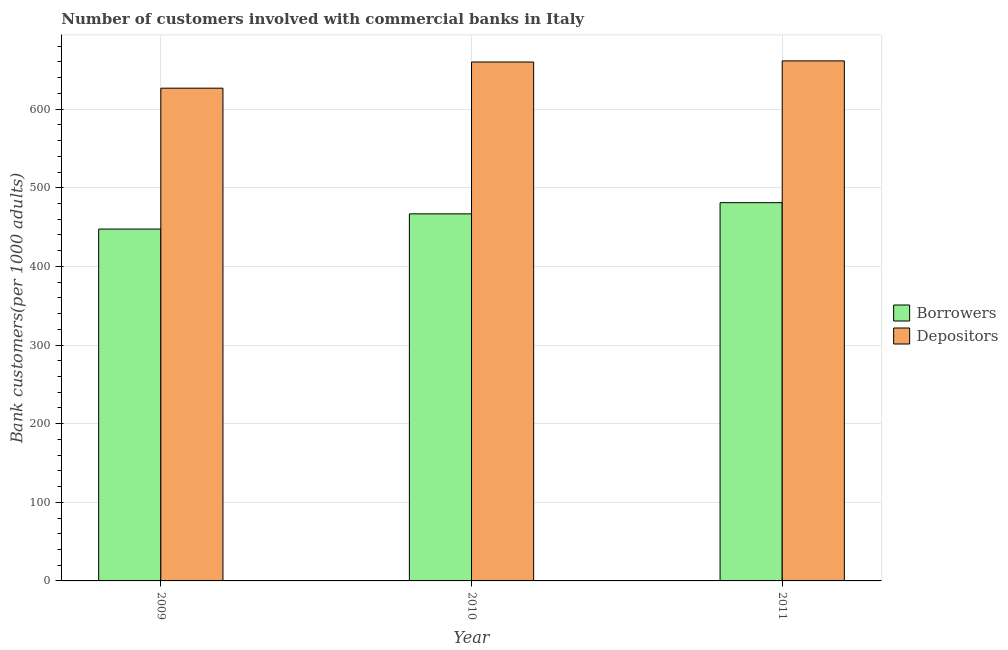How many different coloured bars are there?
Your answer should be very brief. 2. Are the number of bars per tick equal to the number of legend labels?
Keep it short and to the point. Yes. How many bars are there on the 2nd tick from the right?
Give a very brief answer. 2. What is the label of the 3rd group of bars from the left?
Ensure brevity in your answer.  2011. What is the number of borrowers in 2011?
Your answer should be compact. 481.07. Across all years, what is the maximum number of depositors?
Provide a succinct answer. 661.41. Across all years, what is the minimum number of borrowers?
Offer a very short reply. 447.49. In which year was the number of borrowers maximum?
Offer a terse response. 2011. In which year was the number of borrowers minimum?
Your answer should be compact. 2009. What is the total number of borrowers in the graph?
Your answer should be compact. 1395.41. What is the difference between the number of borrowers in 2009 and that in 2010?
Ensure brevity in your answer.  -19.36. What is the difference between the number of borrowers in 2009 and the number of depositors in 2010?
Offer a terse response. -19.36. What is the average number of depositors per year?
Ensure brevity in your answer.  649.36. In how many years, is the number of depositors greater than 180?
Keep it short and to the point. 3. What is the ratio of the number of depositors in 2009 to that in 2010?
Your answer should be compact. 0.95. Is the number of depositors in 2010 less than that in 2011?
Ensure brevity in your answer.  Yes. Is the difference between the number of depositors in 2009 and 2011 greater than the difference between the number of borrowers in 2009 and 2011?
Offer a terse response. No. What is the difference between the highest and the second highest number of depositors?
Your answer should be compact. 1.43. What is the difference between the highest and the lowest number of borrowers?
Provide a short and direct response. 33.58. In how many years, is the number of borrowers greater than the average number of borrowers taken over all years?
Offer a very short reply. 2. Is the sum of the number of borrowers in 2009 and 2011 greater than the maximum number of depositors across all years?
Provide a succinct answer. Yes. What does the 1st bar from the left in 2009 represents?
Provide a succinct answer. Borrowers. What does the 2nd bar from the right in 2010 represents?
Offer a terse response. Borrowers. How many bars are there?
Provide a succinct answer. 6. Are all the bars in the graph horizontal?
Ensure brevity in your answer.  No. What is the difference between two consecutive major ticks on the Y-axis?
Your response must be concise. 100. Does the graph contain grids?
Your answer should be very brief. Yes. How many legend labels are there?
Your answer should be compact. 2. How are the legend labels stacked?
Your answer should be compact. Vertical. What is the title of the graph?
Give a very brief answer. Number of customers involved with commercial banks in Italy. What is the label or title of the Y-axis?
Provide a succinct answer. Bank customers(per 1000 adults). What is the Bank customers(per 1000 adults) in Borrowers in 2009?
Ensure brevity in your answer.  447.49. What is the Bank customers(per 1000 adults) of Depositors in 2009?
Your answer should be very brief. 626.68. What is the Bank customers(per 1000 adults) of Borrowers in 2010?
Give a very brief answer. 466.85. What is the Bank customers(per 1000 adults) of Depositors in 2010?
Give a very brief answer. 659.98. What is the Bank customers(per 1000 adults) in Borrowers in 2011?
Ensure brevity in your answer.  481.07. What is the Bank customers(per 1000 adults) in Depositors in 2011?
Provide a succinct answer. 661.41. Across all years, what is the maximum Bank customers(per 1000 adults) in Borrowers?
Offer a very short reply. 481.07. Across all years, what is the maximum Bank customers(per 1000 adults) in Depositors?
Your answer should be compact. 661.41. Across all years, what is the minimum Bank customers(per 1000 adults) of Borrowers?
Provide a short and direct response. 447.49. Across all years, what is the minimum Bank customers(per 1000 adults) in Depositors?
Make the answer very short. 626.68. What is the total Bank customers(per 1000 adults) of Borrowers in the graph?
Provide a short and direct response. 1395.41. What is the total Bank customers(per 1000 adults) of Depositors in the graph?
Give a very brief answer. 1948.07. What is the difference between the Bank customers(per 1000 adults) in Borrowers in 2009 and that in 2010?
Keep it short and to the point. -19.36. What is the difference between the Bank customers(per 1000 adults) in Depositors in 2009 and that in 2010?
Offer a terse response. -33.3. What is the difference between the Bank customers(per 1000 adults) of Borrowers in 2009 and that in 2011?
Offer a very short reply. -33.58. What is the difference between the Bank customers(per 1000 adults) of Depositors in 2009 and that in 2011?
Ensure brevity in your answer.  -34.73. What is the difference between the Bank customers(per 1000 adults) of Borrowers in 2010 and that in 2011?
Provide a short and direct response. -14.22. What is the difference between the Bank customers(per 1000 adults) of Depositors in 2010 and that in 2011?
Provide a succinct answer. -1.43. What is the difference between the Bank customers(per 1000 adults) in Borrowers in 2009 and the Bank customers(per 1000 adults) in Depositors in 2010?
Your answer should be compact. -212.49. What is the difference between the Bank customers(per 1000 adults) in Borrowers in 2009 and the Bank customers(per 1000 adults) in Depositors in 2011?
Offer a terse response. -213.92. What is the difference between the Bank customers(per 1000 adults) of Borrowers in 2010 and the Bank customers(per 1000 adults) of Depositors in 2011?
Make the answer very short. -194.56. What is the average Bank customers(per 1000 adults) of Borrowers per year?
Provide a short and direct response. 465.14. What is the average Bank customers(per 1000 adults) of Depositors per year?
Offer a terse response. 649.36. In the year 2009, what is the difference between the Bank customers(per 1000 adults) in Borrowers and Bank customers(per 1000 adults) in Depositors?
Provide a short and direct response. -179.19. In the year 2010, what is the difference between the Bank customers(per 1000 adults) of Borrowers and Bank customers(per 1000 adults) of Depositors?
Ensure brevity in your answer.  -193.13. In the year 2011, what is the difference between the Bank customers(per 1000 adults) of Borrowers and Bank customers(per 1000 adults) of Depositors?
Provide a short and direct response. -180.34. What is the ratio of the Bank customers(per 1000 adults) of Borrowers in 2009 to that in 2010?
Make the answer very short. 0.96. What is the ratio of the Bank customers(per 1000 adults) in Depositors in 2009 to that in 2010?
Your answer should be compact. 0.95. What is the ratio of the Bank customers(per 1000 adults) in Borrowers in 2009 to that in 2011?
Your answer should be compact. 0.93. What is the ratio of the Bank customers(per 1000 adults) of Depositors in 2009 to that in 2011?
Offer a terse response. 0.95. What is the ratio of the Bank customers(per 1000 adults) of Borrowers in 2010 to that in 2011?
Offer a very short reply. 0.97. What is the ratio of the Bank customers(per 1000 adults) of Depositors in 2010 to that in 2011?
Your answer should be very brief. 1. What is the difference between the highest and the second highest Bank customers(per 1000 adults) in Borrowers?
Make the answer very short. 14.22. What is the difference between the highest and the second highest Bank customers(per 1000 adults) in Depositors?
Offer a terse response. 1.43. What is the difference between the highest and the lowest Bank customers(per 1000 adults) of Borrowers?
Make the answer very short. 33.58. What is the difference between the highest and the lowest Bank customers(per 1000 adults) of Depositors?
Keep it short and to the point. 34.73. 